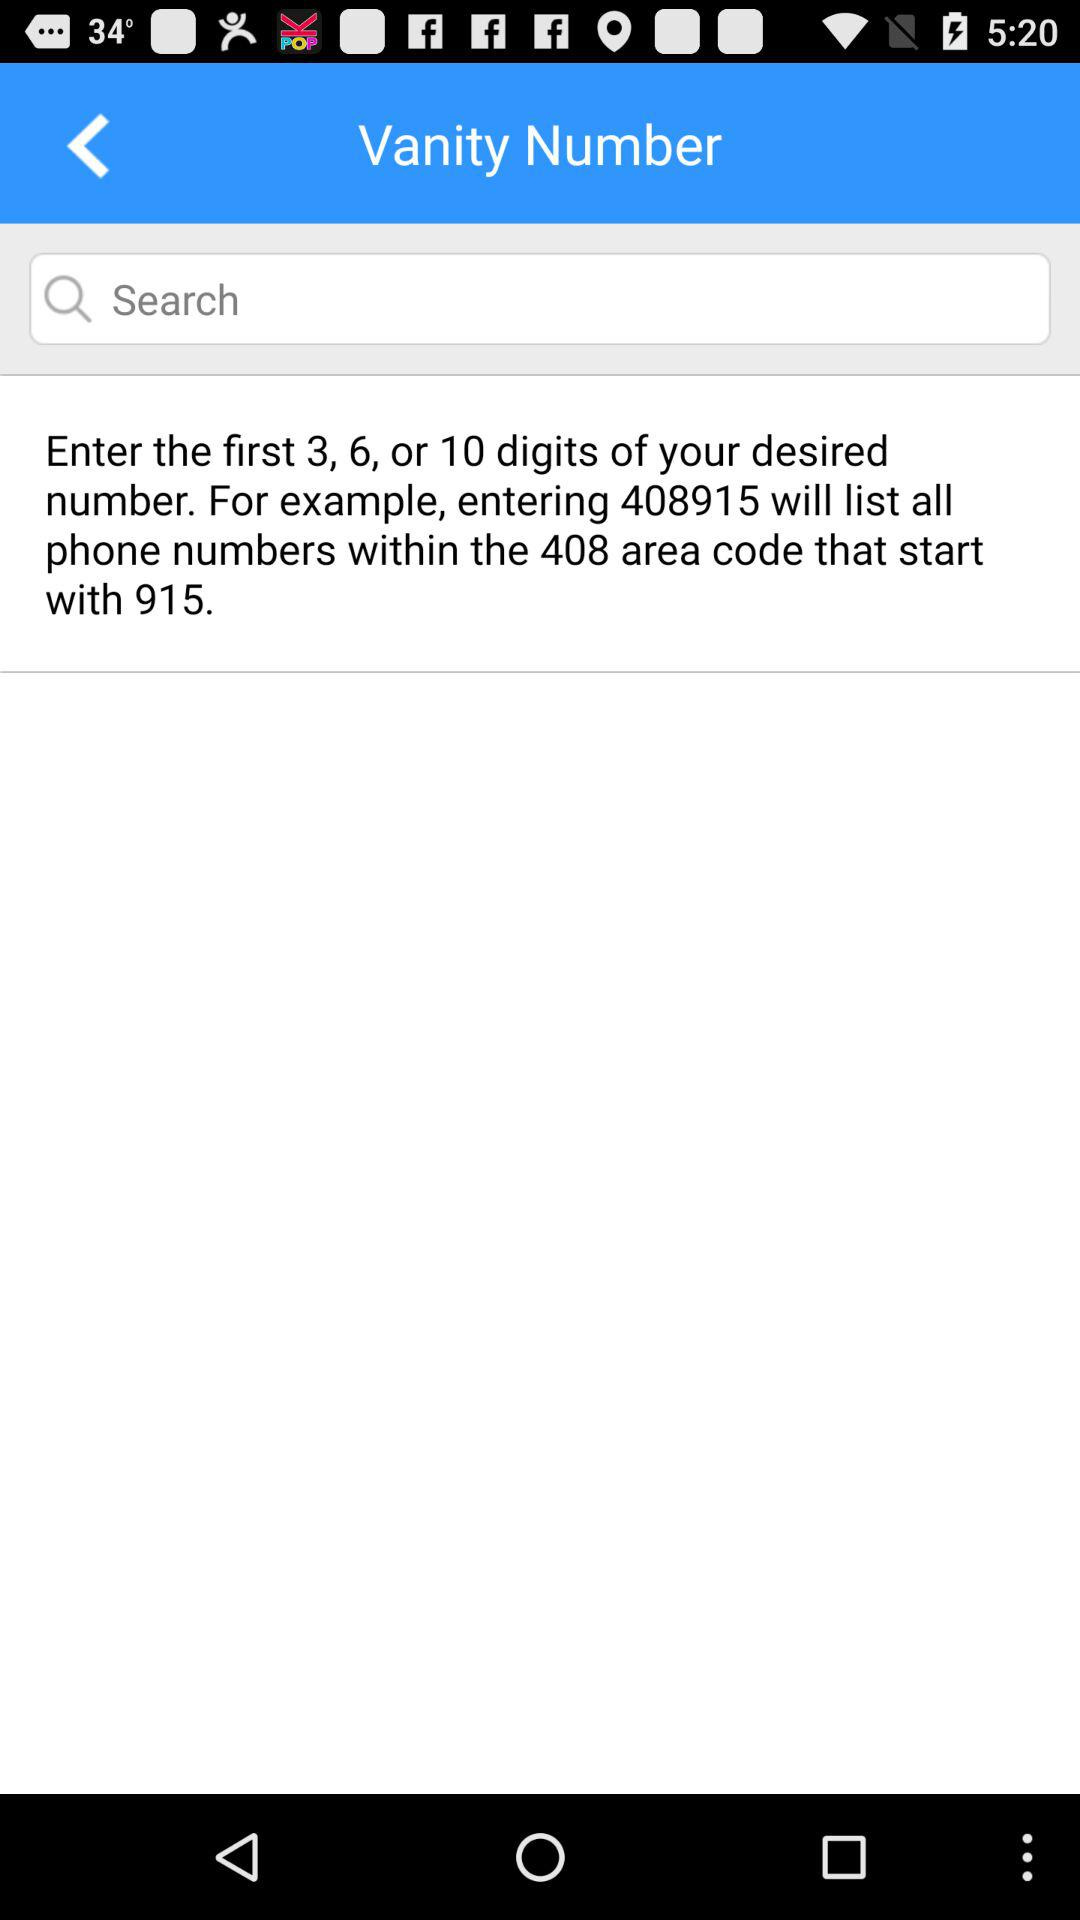What is the given example? The given example is entering 408915 will list all phone numbers within the 408 area code that start with 915. 